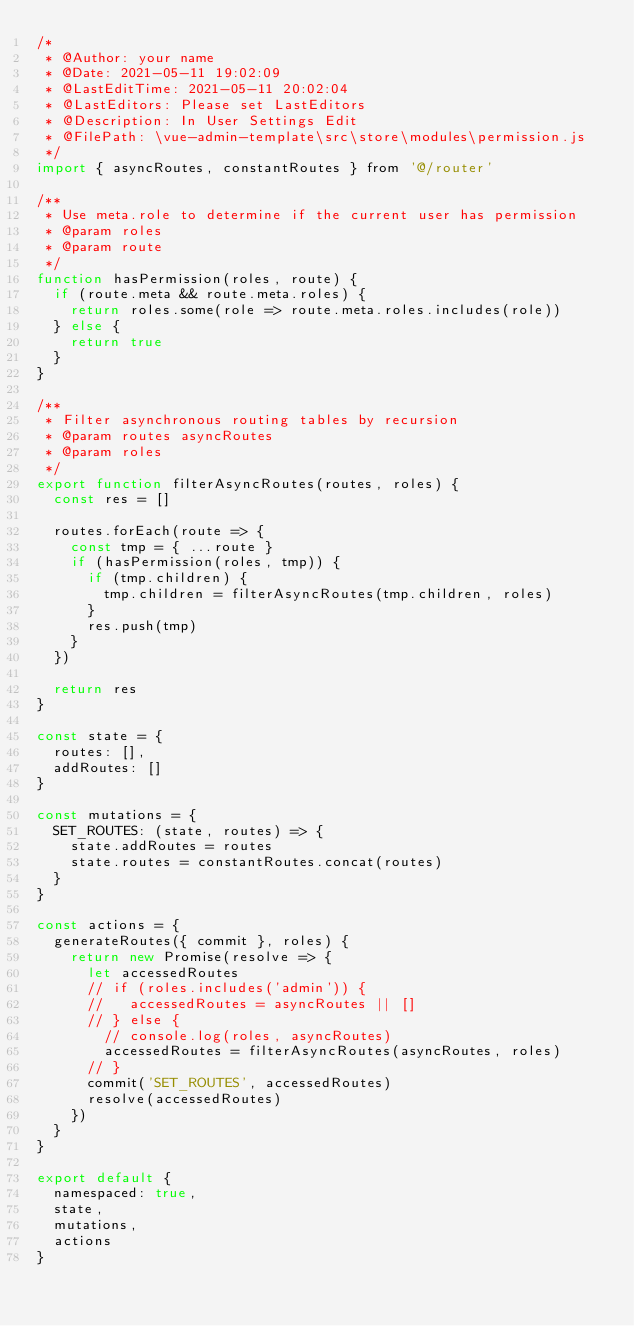<code> <loc_0><loc_0><loc_500><loc_500><_JavaScript_>/*
 * @Author: your name
 * @Date: 2021-05-11 19:02:09
 * @LastEditTime: 2021-05-11 20:02:04
 * @LastEditors: Please set LastEditors
 * @Description: In User Settings Edit
 * @FilePath: \vue-admin-template\src\store\modules\permission.js
 */
import { asyncRoutes, constantRoutes } from '@/router'

/**
 * Use meta.role to determine if the current user has permission
 * @param roles
 * @param route
 */
function hasPermission(roles, route) {
  if (route.meta && route.meta.roles) {
    return roles.some(role => route.meta.roles.includes(role))
  } else {
    return true
  }
}

/**
 * Filter asynchronous routing tables by recursion
 * @param routes asyncRoutes
 * @param roles
 */
export function filterAsyncRoutes(routes, roles) {
  const res = []

  routes.forEach(route => {
    const tmp = { ...route }
    if (hasPermission(roles, tmp)) {
      if (tmp.children) {
        tmp.children = filterAsyncRoutes(tmp.children, roles)
      }
      res.push(tmp)
    }
  })

  return res
}

const state = {
  routes: [],
  addRoutes: []
}

const mutations = {
  SET_ROUTES: (state, routes) => {
    state.addRoutes = routes
    state.routes = constantRoutes.concat(routes)
  }
}

const actions = {
  generateRoutes({ commit }, roles) {
    return new Promise(resolve => {
      let accessedRoutes
      // if (roles.includes('admin')) {
      //   accessedRoutes = asyncRoutes || []
      // } else {
        // console.log(roles, asyncRoutes)
        accessedRoutes = filterAsyncRoutes(asyncRoutes, roles)
      // }
      commit('SET_ROUTES', accessedRoutes)
      resolve(accessedRoutes)
    })
  }
}

export default {
  namespaced: true,
  state,
  mutations,
  actions
}
</code> 